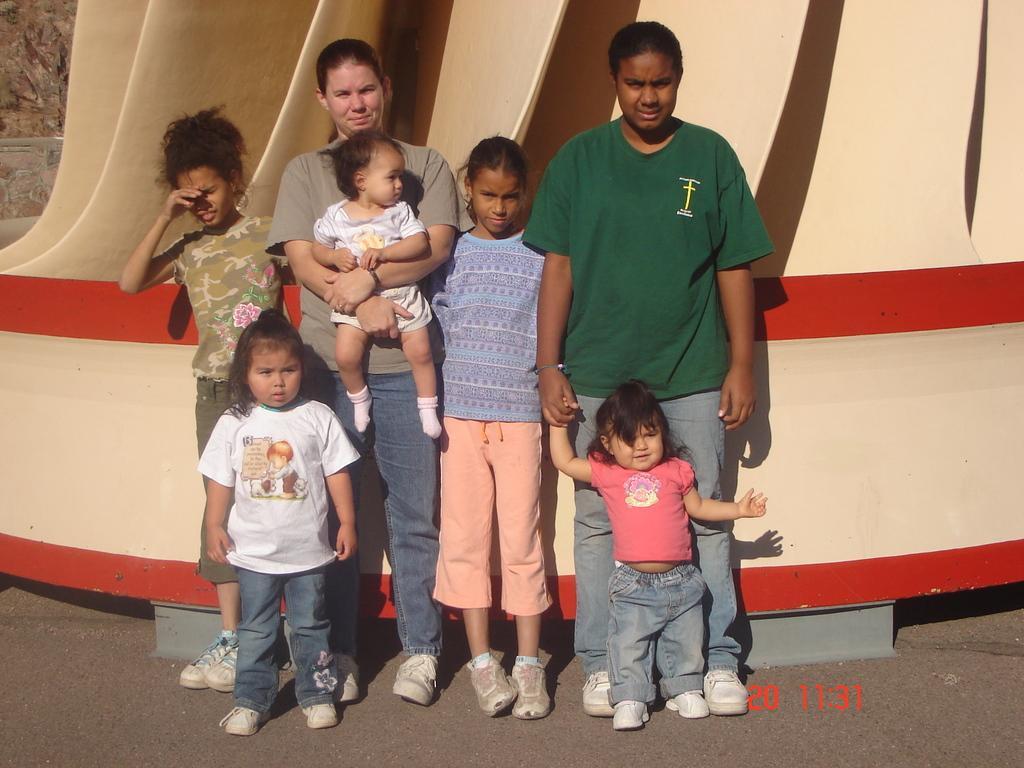How would you summarize this image in a sentence or two? People are standing. A person is holding a baby. Time is mentioned at the bottom. 